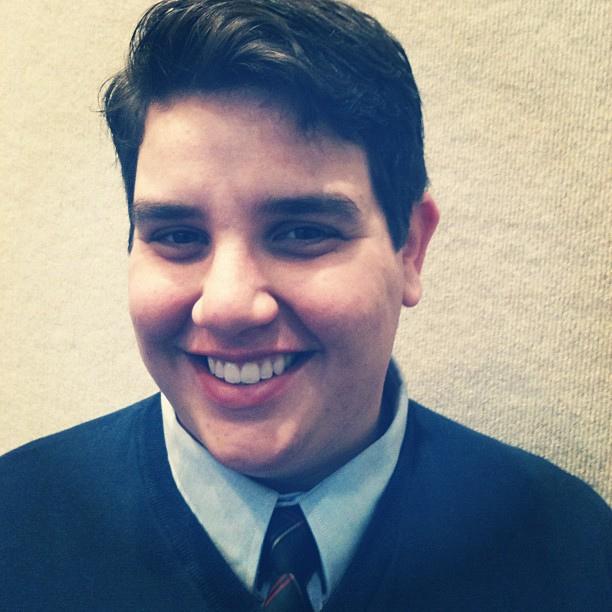Is this man nicely dressed?
Give a very brief answer. Yes. Is this man smiling?
Be succinct. Yes. What gender is this person?
Keep it brief. Male. Has this man had his hair styled?
Write a very short answer. Yes. Does he seem happy?
Give a very brief answer. Yes. 